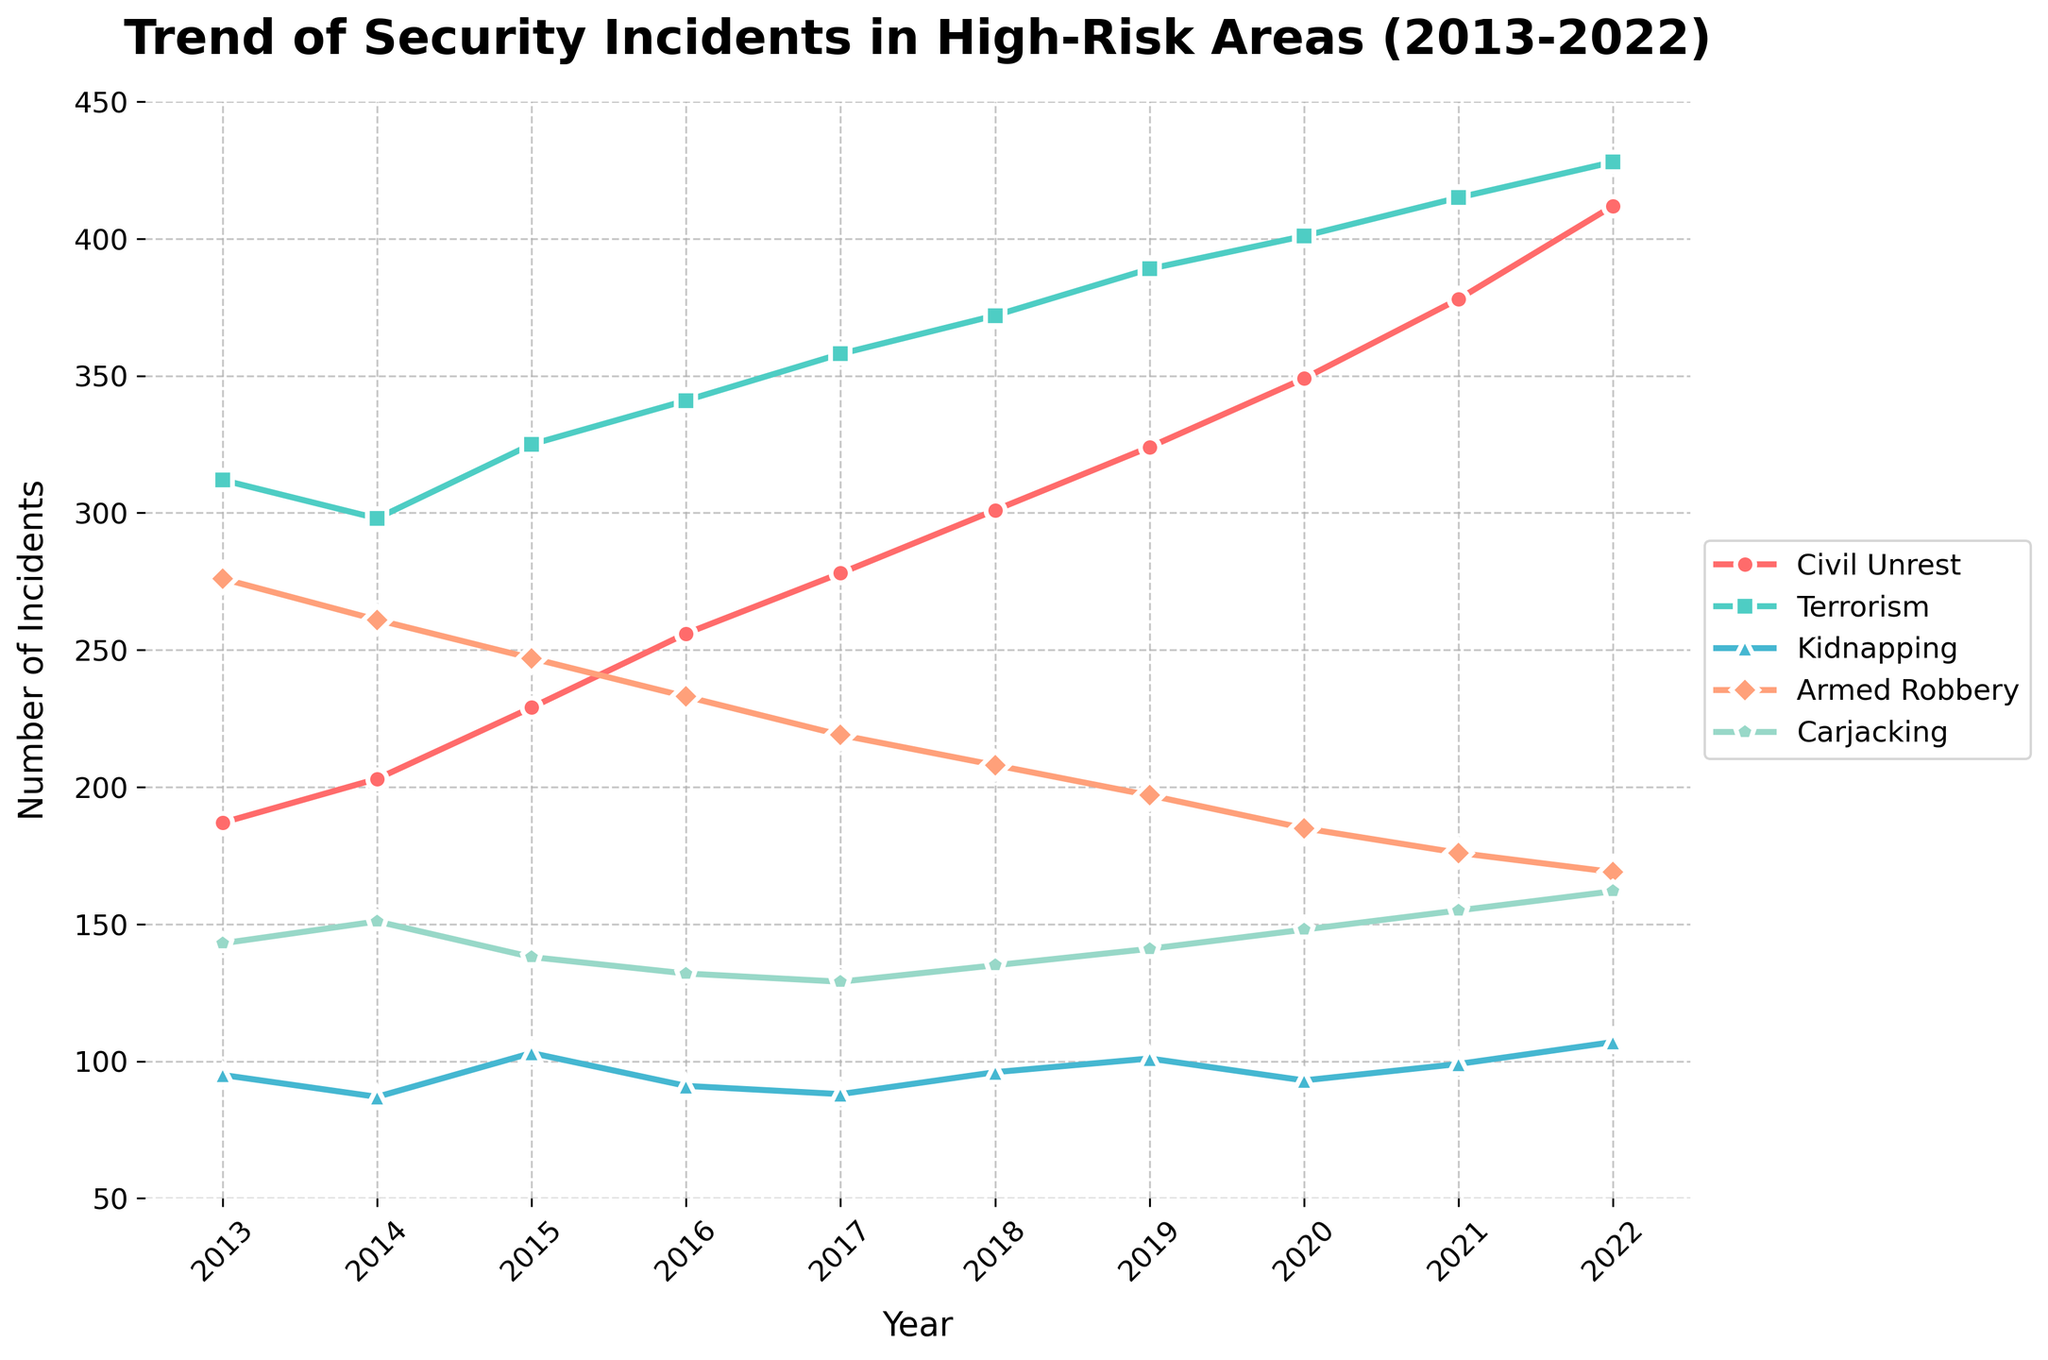What's the overall trend of terrorism incidents from 2013 to 2022? To analyze the trend, observe the line representing terrorism incidents from 2013 to 2022. The line shows an increase overall, indicating a rising trend.
Answer: Rising Which year had the highest number of armed robbery incidents? Look for the peak point on the line representing armed robbery incidents. The highest point is in 2013 with 276 incidents.
Answer: 2013 How did the number of carjacking incidents change from 2019 to 2020? Locate the data points for carjacking in 2019 and 2020. The number increased from 141 in 2019 to 148 in 2020.
Answer: Increased Compare the incidents of civil unrest and kidnapping in the year 2016. Which one was higher? Check the lines for civil unrest and kidnapping in 2016. Civil Unrest had higher incidents (256) compared to kidnapping (91).
Answer: Civil Unrest What's the average number of incidents for carjacking between 2018 and 2022 (inclusive)? Sum the carjacking incidents from 2018 to 2022 (135 + 141 + 148 + 155 + 162) = 741, then divide by the number of years (5). The average is 741/5 = 148.2.
Answer: 148.2 Which type of incident saw the largest increase in number from 2013 to 2022? Calculate the difference for each incident type from 2013 to 2022 and identify the largest: Civil Unrest (412-187=225), Terrorism (428-312=116), Kidnapping (107-95=12), Armed Robbery (169-276=(-107)), Carjacking (162-143=19). Civil Unrest had the largest increase.
Answer: Civil Unrest In which year did the number of kidnapping incidents surpass the number of carjacking incidents for the first time? Compare the lines for kidnapping and carjacking, and observe the point where kidnapping incidents exceed carjacking. The first instance is in 2022 (107 kidnapping vs. 162 carjacking).
Answer: Never What is the overall trend of armed robbery incidents from 2013 to 2022? Examine the line representing armed robbery. It shows a declining trend from 276 in 2013 to 169 in 2022.
Answer: Declining Between civil unrest and terrorism, which had more variability in the number of incidents from 2013 to 2022? Observe the fluctuation in the lines. Civil unrest shows a more steady rise, while terrorism fluctuates less but increases more sharply overall. Civil unrest shows more consistent variability while terrorism shows a significant steady increase.
Answer: Terrorism 